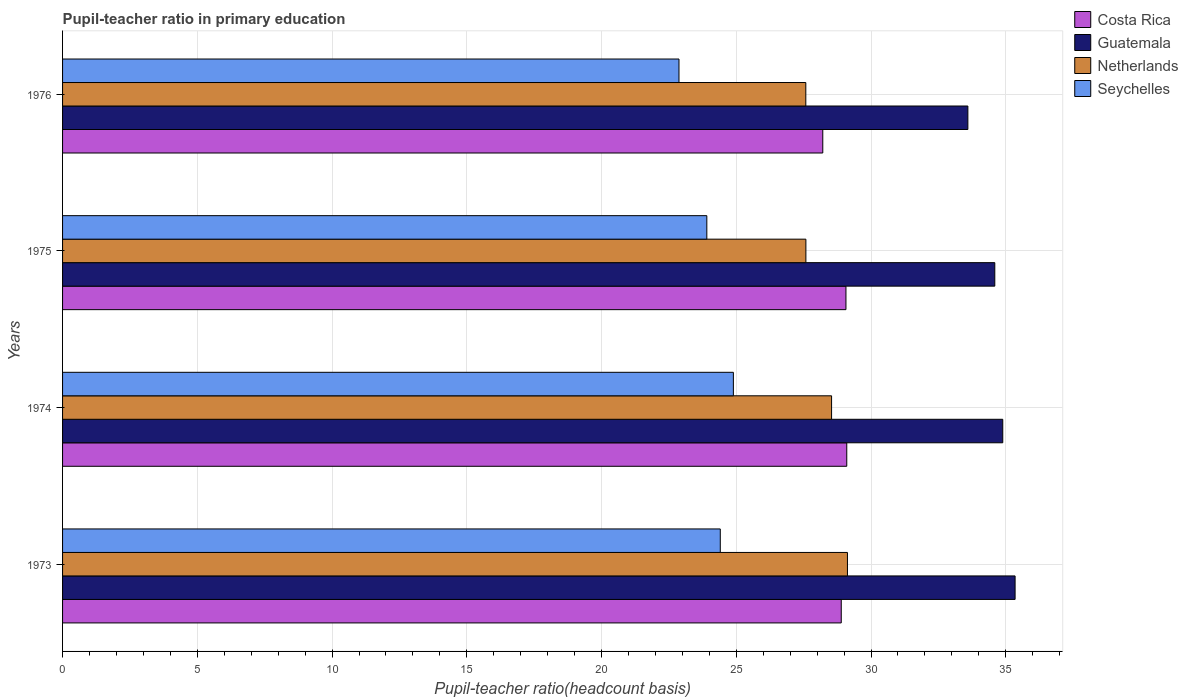How many different coloured bars are there?
Give a very brief answer. 4. How many groups of bars are there?
Ensure brevity in your answer.  4. Are the number of bars per tick equal to the number of legend labels?
Give a very brief answer. Yes. What is the label of the 3rd group of bars from the top?
Provide a succinct answer. 1974. What is the pupil-teacher ratio in primary education in Netherlands in 1973?
Offer a very short reply. 29.12. Across all years, what is the maximum pupil-teacher ratio in primary education in Netherlands?
Make the answer very short. 29.12. Across all years, what is the minimum pupil-teacher ratio in primary education in Netherlands?
Offer a terse response. 27.58. In which year was the pupil-teacher ratio in primary education in Seychelles maximum?
Your response must be concise. 1974. In which year was the pupil-teacher ratio in primary education in Netherlands minimum?
Make the answer very short. 1976. What is the total pupil-teacher ratio in primary education in Netherlands in the graph?
Provide a succinct answer. 112.82. What is the difference between the pupil-teacher ratio in primary education in Netherlands in 1974 and that in 1976?
Your answer should be compact. 0.96. What is the difference between the pupil-teacher ratio in primary education in Costa Rica in 1975 and the pupil-teacher ratio in primary education in Netherlands in 1976?
Your answer should be compact. 1.49. What is the average pupil-teacher ratio in primary education in Seychelles per year?
Your answer should be compact. 24.02. In the year 1974, what is the difference between the pupil-teacher ratio in primary education in Seychelles and pupil-teacher ratio in primary education in Costa Rica?
Keep it short and to the point. -4.21. In how many years, is the pupil-teacher ratio in primary education in Guatemala greater than 8 ?
Keep it short and to the point. 4. What is the ratio of the pupil-teacher ratio in primary education in Netherlands in 1973 to that in 1974?
Ensure brevity in your answer.  1.02. Is the pupil-teacher ratio in primary education in Seychelles in 1973 less than that in 1974?
Offer a very short reply. Yes. What is the difference between the highest and the second highest pupil-teacher ratio in primary education in Guatemala?
Your answer should be very brief. 0.46. What is the difference between the highest and the lowest pupil-teacher ratio in primary education in Costa Rica?
Your answer should be compact. 0.89. Is it the case that in every year, the sum of the pupil-teacher ratio in primary education in Costa Rica and pupil-teacher ratio in primary education in Netherlands is greater than the sum of pupil-teacher ratio in primary education in Guatemala and pupil-teacher ratio in primary education in Seychelles?
Provide a succinct answer. No. What does the 3rd bar from the top in 1976 represents?
Keep it short and to the point. Guatemala. How many years are there in the graph?
Your answer should be very brief. 4. Does the graph contain grids?
Offer a very short reply. Yes. How many legend labels are there?
Make the answer very short. 4. What is the title of the graph?
Keep it short and to the point. Pupil-teacher ratio in primary education. Does "Australia" appear as one of the legend labels in the graph?
Your response must be concise. No. What is the label or title of the X-axis?
Provide a succinct answer. Pupil-teacher ratio(headcount basis). What is the Pupil-teacher ratio(headcount basis) of Costa Rica in 1973?
Offer a terse response. 28.89. What is the Pupil-teacher ratio(headcount basis) in Guatemala in 1973?
Your answer should be very brief. 35.35. What is the Pupil-teacher ratio(headcount basis) in Netherlands in 1973?
Offer a very short reply. 29.12. What is the Pupil-teacher ratio(headcount basis) of Seychelles in 1973?
Make the answer very short. 24.41. What is the Pupil-teacher ratio(headcount basis) in Costa Rica in 1974?
Your response must be concise. 29.1. What is the Pupil-teacher ratio(headcount basis) of Guatemala in 1974?
Keep it short and to the point. 34.89. What is the Pupil-teacher ratio(headcount basis) of Netherlands in 1974?
Provide a short and direct response. 28.54. What is the Pupil-teacher ratio(headcount basis) of Seychelles in 1974?
Your answer should be very brief. 24.89. What is the Pupil-teacher ratio(headcount basis) of Costa Rica in 1975?
Your answer should be very brief. 29.07. What is the Pupil-teacher ratio(headcount basis) in Guatemala in 1975?
Keep it short and to the point. 34.59. What is the Pupil-teacher ratio(headcount basis) of Netherlands in 1975?
Ensure brevity in your answer.  27.58. What is the Pupil-teacher ratio(headcount basis) of Seychelles in 1975?
Your response must be concise. 23.91. What is the Pupil-teacher ratio(headcount basis) in Costa Rica in 1976?
Offer a very short reply. 28.21. What is the Pupil-teacher ratio(headcount basis) in Guatemala in 1976?
Provide a short and direct response. 33.59. What is the Pupil-teacher ratio(headcount basis) of Netherlands in 1976?
Your answer should be compact. 27.58. What is the Pupil-teacher ratio(headcount basis) of Seychelles in 1976?
Provide a short and direct response. 22.87. Across all years, what is the maximum Pupil-teacher ratio(headcount basis) of Costa Rica?
Provide a succinct answer. 29.1. Across all years, what is the maximum Pupil-teacher ratio(headcount basis) of Guatemala?
Offer a terse response. 35.35. Across all years, what is the maximum Pupil-teacher ratio(headcount basis) in Netherlands?
Keep it short and to the point. 29.12. Across all years, what is the maximum Pupil-teacher ratio(headcount basis) in Seychelles?
Your answer should be compact. 24.89. Across all years, what is the minimum Pupil-teacher ratio(headcount basis) of Costa Rica?
Your answer should be compact. 28.21. Across all years, what is the minimum Pupil-teacher ratio(headcount basis) in Guatemala?
Provide a succinct answer. 33.59. Across all years, what is the minimum Pupil-teacher ratio(headcount basis) in Netherlands?
Provide a short and direct response. 27.58. Across all years, what is the minimum Pupil-teacher ratio(headcount basis) in Seychelles?
Your answer should be compact. 22.87. What is the total Pupil-teacher ratio(headcount basis) of Costa Rica in the graph?
Your answer should be very brief. 115.27. What is the total Pupil-teacher ratio(headcount basis) in Guatemala in the graph?
Your answer should be very brief. 138.42. What is the total Pupil-teacher ratio(headcount basis) in Netherlands in the graph?
Offer a terse response. 112.82. What is the total Pupil-teacher ratio(headcount basis) of Seychelles in the graph?
Provide a short and direct response. 96.08. What is the difference between the Pupil-teacher ratio(headcount basis) of Costa Rica in 1973 and that in 1974?
Your answer should be very brief. -0.2. What is the difference between the Pupil-teacher ratio(headcount basis) of Guatemala in 1973 and that in 1974?
Provide a short and direct response. 0.46. What is the difference between the Pupil-teacher ratio(headcount basis) of Netherlands in 1973 and that in 1974?
Offer a very short reply. 0.59. What is the difference between the Pupil-teacher ratio(headcount basis) of Seychelles in 1973 and that in 1974?
Make the answer very short. -0.49. What is the difference between the Pupil-teacher ratio(headcount basis) of Costa Rica in 1973 and that in 1975?
Provide a succinct answer. -0.17. What is the difference between the Pupil-teacher ratio(headcount basis) in Guatemala in 1973 and that in 1975?
Your answer should be compact. 0.75. What is the difference between the Pupil-teacher ratio(headcount basis) of Netherlands in 1973 and that in 1975?
Offer a very short reply. 1.54. What is the difference between the Pupil-teacher ratio(headcount basis) of Seychelles in 1973 and that in 1975?
Provide a succinct answer. 0.5. What is the difference between the Pupil-teacher ratio(headcount basis) of Costa Rica in 1973 and that in 1976?
Keep it short and to the point. 0.69. What is the difference between the Pupil-teacher ratio(headcount basis) of Guatemala in 1973 and that in 1976?
Your response must be concise. 1.75. What is the difference between the Pupil-teacher ratio(headcount basis) in Netherlands in 1973 and that in 1976?
Offer a very short reply. 1.54. What is the difference between the Pupil-teacher ratio(headcount basis) in Seychelles in 1973 and that in 1976?
Make the answer very short. 1.53. What is the difference between the Pupil-teacher ratio(headcount basis) in Costa Rica in 1974 and that in 1975?
Provide a short and direct response. 0.03. What is the difference between the Pupil-teacher ratio(headcount basis) of Guatemala in 1974 and that in 1975?
Offer a very short reply. 0.3. What is the difference between the Pupil-teacher ratio(headcount basis) of Netherlands in 1974 and that in 1975?
Ensure brevity in your answer.  0.95. What is the difference between the Pupil-teacher ratio(headcount basis) in Seychelles in 1974 and that in 1975?
Provide a short and direct response. 0.99. What is the difference between the Pupil-teacher ratio(headcount basis) in Costa Rica in 1974 and that in 1976?
Provide a short and direct response. 0.89. What is the difference between the Pupil-teacher ratio(headcount basis) of Guatemala in 1974 and that in 1976?
Give a very brief answer. 1.29. What is the difference between the Pupil-teacher ratio(headcount basis) of Netherlands in 1974 and that in 1976?
Provide a short and direct response. 0.96. What is the difference between the Pupil-teacher ratio(headcount basis) of Seychelles in 1974 and that in 1976?
Your answer should be compact. 2.02. What is the difference between the Pupil-teacher ratio(headcount basis) in Costa Rica in 1975 and that in 1976?
Keep it short and to the point. 0.86. What is the difference between the Pupil-teacher ratio(headcount basis) in Netherlands in 1975 and that in 1976?
Provide a succinct answer. 0. What is the difference between the Pupil-teacher ratio(headcount basis) in Seychelles in 1975 and that in 1976?
Your response must be concise. 1.03. What is the difference between the Pupil-teacher ratio(headcount basis) in Costa Rica in 1973 and the Pupil-teacher ratio(headcount basis) in Guatemala in 1974?
Offer a terse response. -5.99. What is the difference between the Pupil-teacher ratio(headcount basis) of Costa Rica in 1973 and the Pupil-teacher ratio(headcount basis) of Netherlands in 1974?
Offer a very short reply. 0.36. What is the difference between the Pupil-teacher ratio(headcount basis) of Costa Rica in 1973 and the Pupil-teacher ratio(headcount basis) of Seychelles in 1974?
Offer a terse response. 4. What is the difference between the Pupil-teacher ratio(headcount basis) of Guatemala in 1973 and the Pupil-teacher ratio(headcount basis) of Netherlands in 1974?
Offer a very short reply. 6.81. What is the difference between the Pupil-teacher ratio(headcount basis) in Guatemala in 1973 and the Pupil-teacher ratio(headcount basis) in Seychelles in 1974?
Your response must be concise. 10.45. What is the difference between the Pupil-teacher ratio(headcount basis) of Netherlands in 1973 and the Pupil-teacher ratio(headcount basis) of Seychelles in 1974?
Keep it short and to the point. 4.23. What is the difference between the Pupil-teacher ratio(headcount basis) of Costa Rica in 1973 and the Pupil-teacher ratio(headcount basis) of Guatemala in 1975?
Make the answer very short. -5.7. What is the difference between the Pupil-teacher ratio(headcount basis) in Costa Rica in 1973 and the Pupil-teacher ratio(headcount basis) in Netherlands in 1975?
Ensure brevity in your answer.  1.31. What is the difference between the Pupil-teacher ratio(headcount basis) in Costa Rica in 1973 and the Pupil-teacher ratio(headcount basis) in Seychelles in 1975?
Your response must be concise. 4.99. What is the difference between the Pupil-teacher ratio(headcount basis) in Guatemala in 1973 and the Pupil-teacher ratio(headcount basis) in Netherlands in 1975?
Make the answer very short. 7.76. What is the difference between the Pupil-teacher ratio(headcount basis) in Guatemala in 1973 and the Pupil-teacher ratio(headcount basis) in Seychelles in 1975?
Make the answer very short. 11.44. What is the difference between the Pupil-teacher ratio(headcount basis) in Netherlands in 1973 and the Pupil-teacher ratio(headcount basis) in Seychelles in 1975?
Your response must be concise. 5.22. What is the difference between the Pupil-teacher ratio(headcount basis) in Costa Rica in 1973 and the Pupil-teacher ratio(headcount basis) in Guatemala in 1976?
Provide a succinct answer. -4.7. What is the difference between the Pupil-teacher ratio(headcount basis) in Costa Rica in 1973 and the Pupil-teacher ratio(headcount basis) in Netherlands in 1976?
Offer a terse response. 1.31. What is the difference between the Pupil-teacher ratio(headcount basis) of Costa Rica in 1973 and the Pupil-teacher ratio(headcount basis) of Seychelles in 1976?
Your response must be concise. 6.02. What is the difference between the Pupil-teacher ratio(headcount basis) in Guatemala in 1973 and the Pupil-teacher ratio(headcount basis) in Netherlands in 1976?
Provide a short and direct response. 7.77. What is the difference between the Pupil-teacher ratio(headcount basis) in Guatemala in 1973 and the Pupil-teacher ratio(headcount basis) in Seychelles in 1976?
Offer a terse response. 12.47. What is the difference between the Pupil-teacher ratio(headcount basis) of Netherlands in 1973 and the Pupil-teacher ratio(headcount basis) of Seychelles in 1976?
Make the answer very short. 6.25. What is the difference between the Pupil-teacher ratio(headcount basis) in Costa Rica in 1974 and the Pupil-teacher ratio(headcount basis) in Guatemala in 1975?
Offer a terse response. -5.49. What is the difference between the Pupil-teacher ratio(headcount basis) of Costa Rica in 1974 and the Pupil-teacher ratio(headcount basis) of Netherlands in 1975?
Provide a short and direct response. 1.52. What is the difference between the Pupil-teacher ratio(headcount basis) in Costa Rica in 1974 and the Pupil-teacher ratio(headcount basis) in Seychelles in 1975?
Your response must be concise. 5.19. What is the difference between the Pupil-teacher ratio(headcount basis) of Guatemala in 1974 and the Pupil-teacher ratio(headcount basis) of Netherlands in 1975?
Ensure brevity in your answer.  7.31. What is the difference between the Pupil-teacher ratio(headcount basis) in Guatemala in 1974 and the Pupil-teacher ratio(headcount basis) in Seychelles in 1975?
Ensure brevity in your answer.  10.98. What is the difference between the Pupil-teacher ratio(headcount basis) of Netherlands in 1974 and the Pupil-teacher ratio(headcount basis) of Seychelles in 1975?
Make the answer very short. 4.63. What is the difference between the Pupil-teacher ratio(headcount basis) of Costa Rica in 1974 and the Pupil-teacher ratio(headcount basis) of Guatemala in 1976?
Give a very brief answer. -4.49. What is the difference between the Pupil-teacher ratio(headcount basis) in Costa Rica in 1974 and the Pupil-teacher ratio(headcount basis) in Netherlands in 1976?
Give a very brief answer. 1.52. What is the difference between the Pupil-teacher ratio(headcount basis) in Costa Rica in 1974 and the Pupil-teacher ratio(headcount basis) in Seychelles in 1976?
Make the answer very short. 6.23. What is the difference between the Pupil-teacher ratio(headcount basis) of Guatemala in 1974 and the Pupil-teacher ratio(headcount basis) of Netherlands in 1976?
Provide a succinct answer. 7.31. What is the difference between the Pupil-teacher ratio(headcount basis) of Guatemala in 1974 and the Pupil-teacher ratio(headcount basis) of Seychelles in 1976?
Offer a terse response. 12.01. What is the difference between the Pupil-teacher ratio(headcount basis) of Netherlands in 1974 and the Pupil-teacher ratio(headcount basis) of Seychelles in 1976?
Offer a very short reply. 5.66. What is the difference between the Pupil-teacher ratio(headcount basis) in Costa Rica in 1975 and the Pupil-teacher ratio(headcount basis) in Guatemala in 1976?
Offer a very short reply. -4.52. What is the difference between the Pupil-teacher ratio(headcount basis) in Costa Rica in 1975 and the Pupil-teacher ratio(headcount basis) in Netherlands in 1976?
Give a very brief answer. 1.49. What is the difference between the Pupil-teacher ratio(headcount basis) of Costa Rica in 1975 and the Pupil-teacher ratio(headcount basis) of Seychelles in 1976?
Keep it short and to the point. 6.2. What is the difference between the Pupil-teacher ratio(headcount basis) in Guatemala in 1975 and the Pupil-teacher ratio(headcount basis) in Netherlands in 1976?
Your answer should be very brief. 7.01. What is the difference between the Pupil-teacher ratio(headcount basis) of Guatemala in 1975 and the Pupil-teacher ratio(headcount basis) of Seychelles in 1976?
Provide a succinct answer. 11.72. What is the difference between the Pupil-teacher ratio(headcount basis) of Netherlands in 1975 and the Pupil-teacher ratio(headcount basis) of Seychelles in 1976?
Offer a terse response. 4.71. What is the average Pupil-teacher ratio(headcount basis) of Costa Rica per year?
Make the answer very short. 28.82. What is the average Pupil-teacher ratio(headcount basis) in Guatemala per year?
Offer a very short reply. 34.6. What is the average Pupil-teacher ratio(headcount basis) in Netherlands per year?
Your answer should be very brief. 28.21. What is the average Pupil-teacher ratio(headcount basis) in Seychelles per year?
Keep it short and to the point. 24.02. In the year 1973, what is the difference between the Pupil-teacher ratio(headcount basis) of Costa Rica and Pupil-teacher ratio(headcount basis) of Guatemala?
Give a very brief answer. -6.45. In the year 1973, what is the difference between the Pupil-teacher ratio(headcount basis) in Costa Rica and Pupil-teacher ratio(headcount basis) in Netherlands?
Give a very brief answer. -0.23. In the year 1973, what is the difference between the Pupil-teacher ratio(headcount basis) in Costa Rica and Pupil-teacher ratio(headcount basis) in Seychelles?
Provide a short and direct response. 4.49. In the year 1973, what is the difference between the Pupil-teacher ratio(headcount basis) of Guatemala and Pupil-teacher ratio(headcount basis) of Netherlands?
Ensure brevity in your answer.  6.22. In the year 1973, what is the difference between the Pupil-teacher ratio(headcount basis) in Guatemala and Pupil-teacher ratio(headcount basis) in Seychelles?
Provide a succinct answer. 10.94. In the year 1973, what is the difference between the Pupil-teacher ratio(headcount basis) in Netherlands and Pupil-teacher ratio(headcount basis) in Seychelles?
Provide a short and direct response. 4.72. In the year 1974, what is the difference between the Pupil-teacher ratio(headcount basis) in Costa Rica and Pupil-teacher ratio(headcount basis) in Guatemala?
Offer a terse response. -5.79. In the year 1974, what is the difference between the Pupil-teacher ratio(headcount basis) in Costa Rica and Pupil-teacher ratio(headcount basis) in Netherlands?
Keep it short and to the point. 0.56. In the year 1974, what is the difference between the Pupil-teacher ratio(headcount basis) in Costa Rica and Pupil-teacher ratio(headcount basis) in Seychelles?
Offer a terse response. 4.21. In the year 1974, what is the difference between the Pupil-teacher ratio(headcount basis) of Guatemala and Pupil-teacher ratio(headcount basis) of Netherlands?
Provide a succinct answer. 6.35. In the year 1974, what is the difference between the Pupil-teacher ratio(headcount basis) in Guatemala and Pupil-teacher ratio(headcount basis) in Seychelles?
Offer a terse response. 10. In the year 1974, what is the difference between the Pupil-teacher ratio(headcount basis) in Netherlands and Pupil-teacher ratio(headcount basis) in Seychelles?
Make the answer very short. 3.64. In the year 1975, what is the difference between the Pupil-teacher ratio(headcount basis) in Costa Rica and Pupil-teacher ratio(headcount basis) in Guatemala?
Make the answer very short. -5.52. In the year 1975, what is the difference between the Pupil-teacher ratio(headcount basis) in Costa Rica and Pupil-teacher ratio(headcount basis) in Netherlands?
Make the answer very short. 1.49. In the year 1975, what is the difference between the Pupil-teacher ratio(headcount basis) in Costa Rica and Pupil-teacher ratio(headcount basis) in Seychelles?
Ensure brevity in your answer.  5.16. In the year 1975, what is the difference between the Pupil-teacher ratio(headcount basis) of Guatemala and Pupil-teacher ratio(headcount basis) of Netherlands?
Give a very brief answer. 7.01. In the year 1975, what is the difference between the Pupil-teacher ratio(headcount basis) in Guatemala and Pupil-teacher ratio(headcount basis) in Seychelles?
Keep it short and to the point. 10.69. In the year 1975, what is the difference between the Pupil-teacher ratio(headcount basis) of Netherlands and Pupil-teacher ratio(headcount basis) of Seychelles?
Offer a terse response. 3.68. In the year 1976, what is the difference between the Pupil-teacher ratio(headcount basis) of Costa Rica and Pupil-teacher ratio(headcount basis) of Guatemala?
Provide a succinct answer. -5.38. In the year 1976, what is the difference between the Pupil-teacher ratio(headcount basis) of Costa Rica and Pupil-teacher ratio(headcount basis) of Netherlands?
Your answer should be compact. 0.63. In the year 1976, what is the difference between the Pupil-teacher ratio(headcount basis) of Costa Rica and Pupil-teacher ratio(headcount basis) of Seychelles?
Your answer should be very brief. 5.34. In the year 1976, what is the difference between the Pupil-teacher ratio(headcount basis) in Guatemala and Pupil-teacher ratio(headcount basis) in Netherlands?
Make the answer very short. 6.01. In the year 1976, what is the difference between the Pupil-teacher ratio(headcount basis) in Guatemala and Pupil-teacher ratio(headcount basis) in Seychelles?
Offer a terse response. 10.72. In the year 1976, what is the difference between the Pupil-teacher ratio(headcount basis) in Netherlands and Pupil-teacher ratio(headcount basis) in Seychelles?
Provide a succinct answer. 4.71. What is the ratio of the Pupil-teacher ratio(headcount basis) of Guatemala in 1973 to that in 1974?
Ensure brevity in your answer.  1.01. What is the ratio of the Pupil-teacher ratio(headcount basis) in Netherlands in 1973 to that in 1974?
Ensure brevity in your answer.  1.02. What is the ratio of the Pupil-teacher ratio(headcount basis) in Seychelles in 1973 to that in 1974?
Keep it short and to the point. 0.98. What is the ratio of the Pupil-teacher ratio(headcount basis) of Costa Rica in 1973 to that in 1975?
Provide a short and direct response. 0.99. What is the ratio of the Pupil-teacher ratio(headcount basis) of Guatemala in 1973 to that in 1975?
Give a very brief answer. 1.02. What is the ratio of the Pupil-teacher ratio(headcount basis) of Netherlands in 1973 to that in 1975?
Give a very brief answer. 1.06. What is the ratio of the Pupil-teacher ratio(headcount basis) in Seychelles in 1973 to that in 1975?
Make the answer very short. 1.02. What is the ratio of the Pupil-teacher ratio(headcount basis) of Costa Rica in 1973 to that in 1976?
Keep it short and to the point. 1.02. What is the ratio of the Pupil-teacher ratio(headcount basis) of Guatemala in 1973 to that in 1976?
Ensure brevity in your answer.  1.05. What is the ratio of the Pupil-teacher ratio(headcount basis) of Netherlands in 1973 to that in 1976?
Provide a short and direct response. 1.06. What is the ratio of the Pupil-teacher ratio(headcount basis) in Seychelles in 1973 to that in 1976?
Your response must be concise. 1.07. What is the ratio of the Pupil-teacher ratio(headcount basis) in Guatemala in 1974 to that in 1975?
Provide a short and direct response. 1.01. What is the ratio of the Pupil-teacher ratio(headcount basis) in Netherlands in 1974 to that in 1975?
Your response must be concise. 1.03. What is the ratio of the Pupil-teacher ratio(headcount basis) in Seychelles in 1974 to that in 1975?
Offer a terse response. 1.04. What is the ratio of the Pupil-teacher ratio(headcount basis) in Costa Rica in 1974 to that in 1976?
Offer a very short reply. 1.03. What is the ratio of the Pupil-teacher ratio(headcount basis) of Guatemala in 1974 to that in 1976?
Your answer should be very brief. 1.04. What is the ratio of the Pupil-teacher ratio(headcount basis) in Netherlands in 1974 to that in 1976?
Provide a succinct answer. 1.03. What is the ratio of the Pupil-teacher ratio(headcount basis) in Seychelles in 1974 to that in 1976?
Ensure brevity in your answer.  1.09. What is the ratio of the Pupil-teacher ratio(headcount basis) of Costa Rica in 1975 to that in 1976?
Provide a short and direct response. 1.03. What is the ratio of the Pupil-teacher ratio(headcount basis) of Guatemala in 1975 to that in 1976?
Ensure brevity in your answer.  1.03. What is the ratio of the Pupil-teacher ratio(headcount basis) in Seychelles in 1975 to that in 1976?
Provide a short and direct response. 1.05. What is the difference between the highest and the second highest Pupil-teacher ratio(headcount basis) of Costa Rica?
Your answer should be compact. 0.03. What is the difference between the highest and the second highest Pupil-teacher ratio(headcount basis) of Guatemala?
Give a very brief answer. 0.46. What is the difference between the highest and the second highest Pupil-teacher ratio(headcount basis) in Netherlands?
Your answer should be compact. 0.59. What is the difference between the highest and the second highest Pupil-teacher ratio(headcount basis) of Seychelles?
Offer a very short reply. 0.49. What is the difference between the highest and the lowest Pupil-teacher ratio(headcount basis) in Costa Rica?
Provide a short and direct response. 0.89. What is the difference between the highest and the lowest Pupil-teacher ratio(headcount basis) of Guatemala?
Your answer should be compact. 1.75. What is the difference between the highest and the lowest Pupil-teacher ratio(headcount basis) of Netherlands?
Make the answer very short. 1.54. What is the difference between the highest and the lowest Pupil-teacher ratio(headcount basis) in Seychelles?
Give a very brief answer. 2.02. 